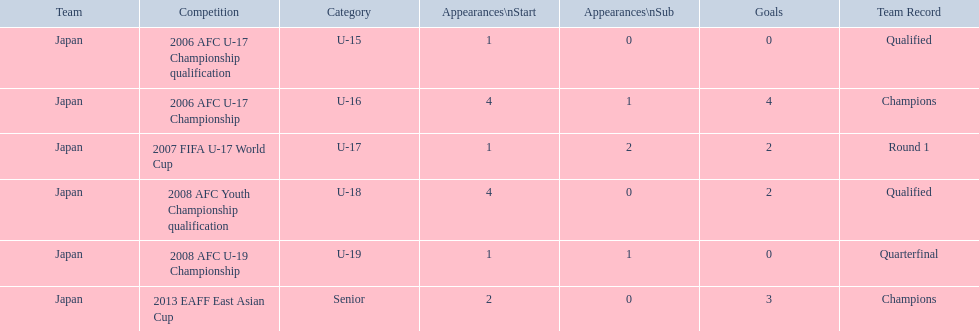What was the team's performance in 2006? Round 1. To which contest did it pertain? 2006 AFC U-17 Championship. 